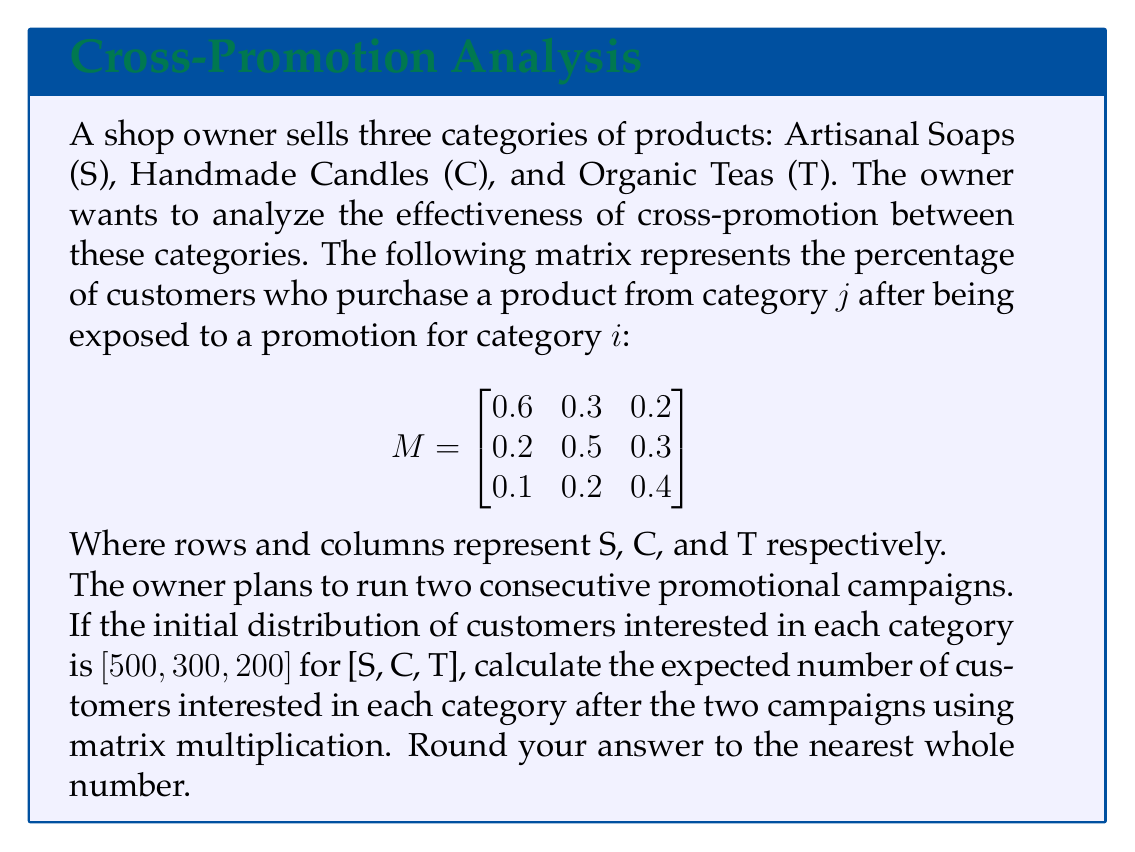Provide a solution to this math problem. Let's approach this step-by-step:

1) First, we need to understand what the matrix multiplication represents. Multiplying the initial distribution by the promotion matrix once will give us the distribution after one campaign. Doing it twice will give us the distribution after two campaigns.

2) Let's call our initial distribution vector $v_0 = [500, 300, 200]$.

3) After the first campaign, the distribution will be:

   $v_1 = v_0 \cdot M$

4) After the second campaign, it will be:

   $v_2 = v_1 \cdot M = (v_0 \cdot M) \cdot M = v_0 \cdot M^2$

5) So, we need to calculate $M^2$ first:

   $$
   M^2 = \begin{bmatrix}
   0.6 & 0.3 & 0.2 \\
   0.2 & 0.5 & 0.3 \\
   0.1 & 0.2 & 0.4
   \end{bmatrix} \cdot 
   \begin{bmatrix}
   0.6 & 0.3 & 0.2 \\
   0.2 & 0.5 & 0.3 \\
   0.1 & 0.2 & 0.4
   \end{bmatrix}
   $$

6) Calculating $M^2$:

   $$
   M^2 = \begin{bmatrix}
   0.44 & 0.37 & 0.28 \\
   0.31 & 0.38 & 0.33 \\
   0.17 & 0.26 & 0.31
   \end{bmatrix}
   $$

7) Now, we multiply $v_0$ by $M^2$:

   $v_2 = [500, 300, 200] \cdot \begin{bmatrix}
   0.44 & 0.37 & 0.28 \\
   0.31 & 0.38 & 0.33 \\
   0.17 & 0.26 & 0.31
   \end{bmatrix}$

8) Calculating:

   $v_2 = [386, 355, 298]$

9) Rounding to the nearest whole number:

   $v_2 \approx [386, 355, 298]$
Answer: [386, 355, 298] 